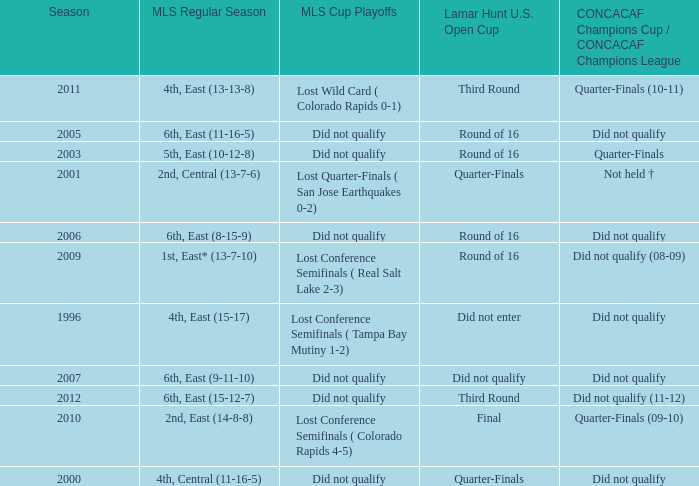What was the mls cup playoffs when concacaf champions cup / concacaf champions league was quarter-finals (09-10)? Lost Conference Semifinals ( Colorado Rapids 4-5). 